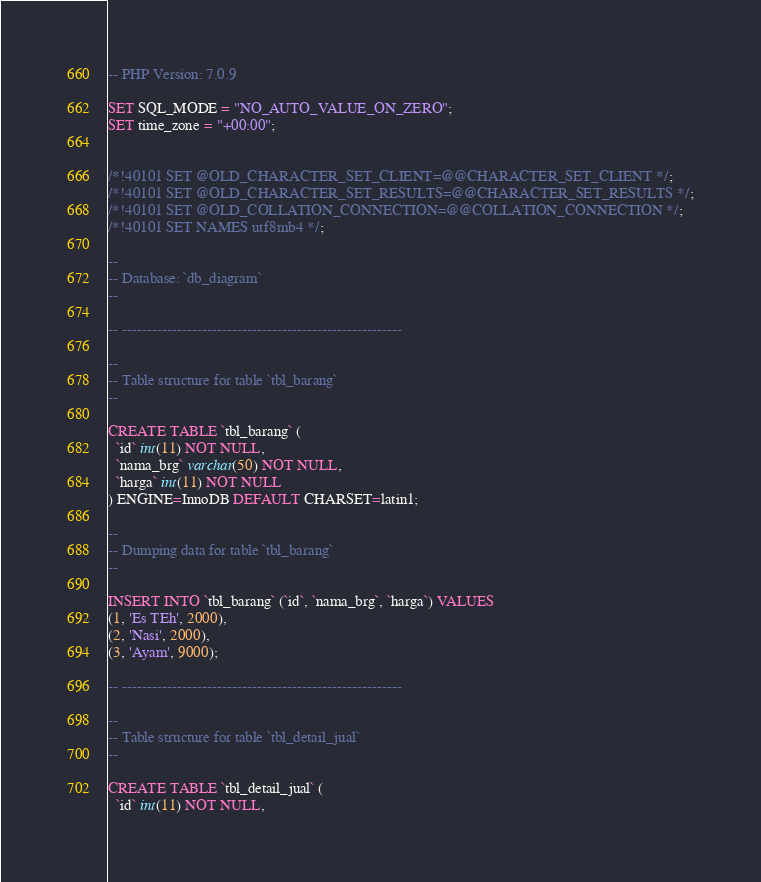Convert code to text. <code><loc_0><loc_0><loc_500><loc_500><_SQL_>-- PHP Version: 7.0.9

SET SQL_MODE = "NO_AUTO_VALUE_ON_ZERO";
SET time_zone = "+00:00";


/*!40101 SET @OLD_CHARACTER_SET_CLIENT=@@CHARACTER_SET_CLIENT */;
/*!40101 SET @OLD_CHARACTER_SET_RESULTS=@@CHARACTER_SET_RESULTS */;
/*!40101 SET @OLD_COLLATION_CONNECTION=@@COLLATION_CONNECTION */;
/*!40101 SET NAMES utf8mb4 */;

--
-- Database: `db_diagram`
--

-- --------------------------------------------------------

--
-- Table structure for table `tbl_barang`
--

CREATE TABLE `tbl_barang` (
  `id` int(11) NOT NULL,
  `nama_brg` varchar(50) NOT NULL,
  `harga` int(11) NOT NULL
) ENGINE=InnoDB DEFAULT CHARSET=latin1;

--
-- Dumping data for table `tbl_barang`
--

INSERT INTO `tbl_barang` (`id`, `nama_brg`, `harga`) VALUES
(1, 'Es TEh', 2000),
(2, 'Nasi', 2000),
(3, 'Ayam', 9000);

-- --------------------------------------------------------

--
-- Table structure for table `tbl_detail_jual`
--

CREATE TABLE `tbl_detail_jual` (
  `id` int(11) NOT NULL,</code> 